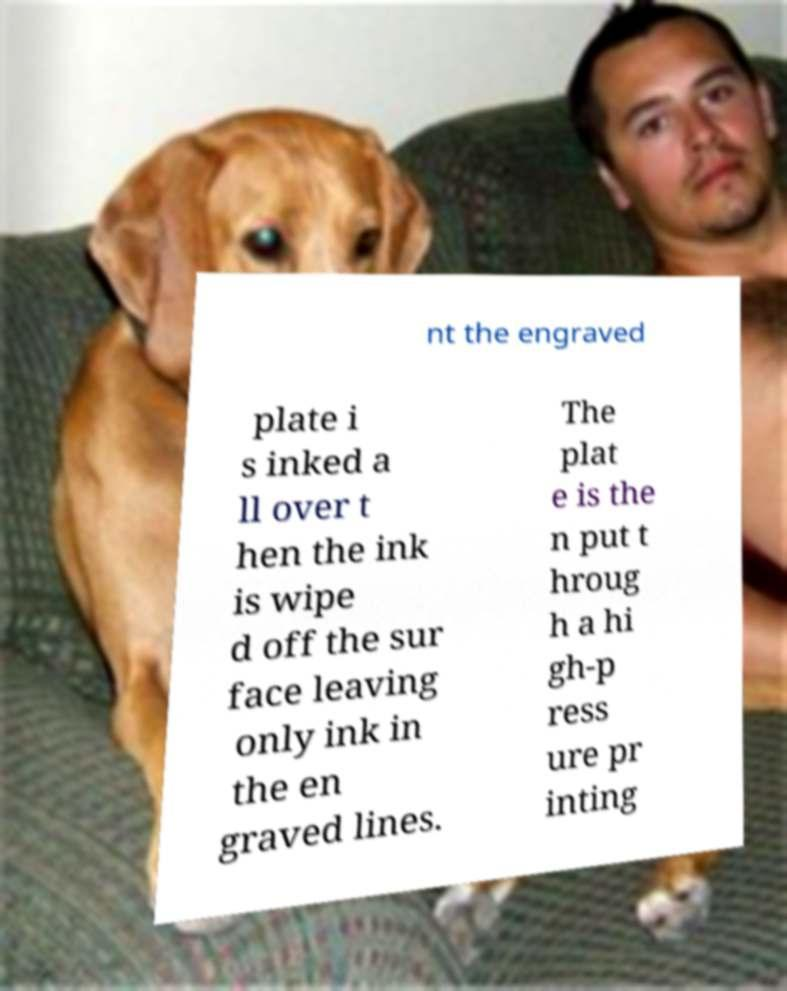For documentation purposes, I need the text within this image transcribed. Could you provide that? nt the engraved plate i s inked a ll over t hen the ink is wipe d off the sur face leaving only ink in the en graved lines. The plat e is the n put t hroug h a hi gh-p ress ure pr inting 